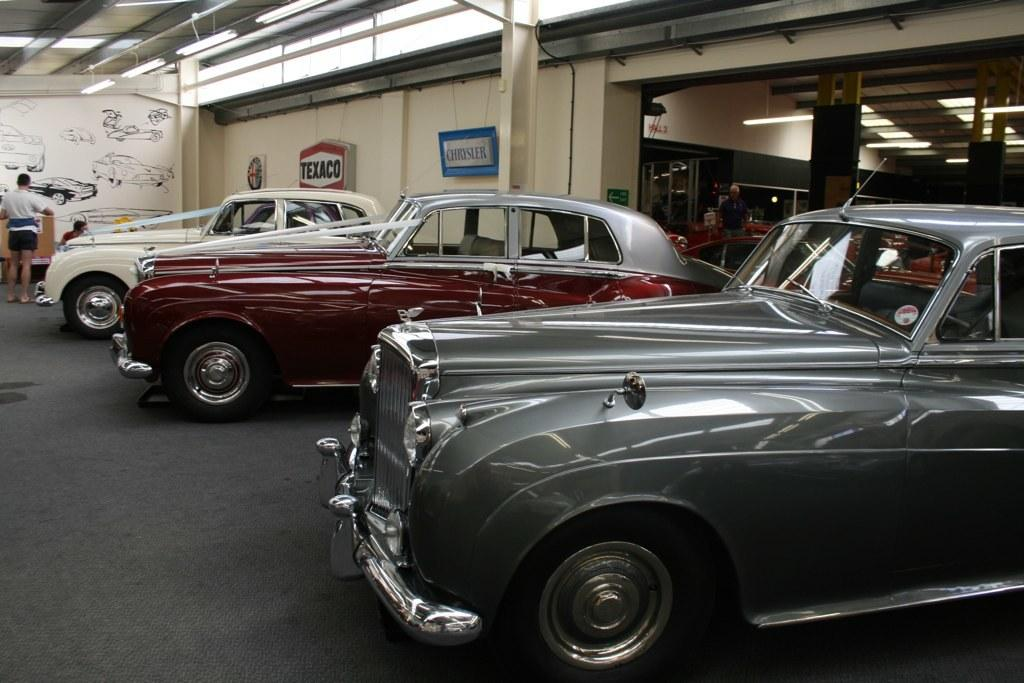What is the main subject of the image? The main subject of the image is many cars. Can you describe one of the cars in the image? One of the cars is gray. Is there anyone else visible in the image besides the cars? Yes, there is a person standing in the background. What can be seen in the background of the image? There is a wall in the background, which is cream-colored, and there are boards hanging on a pole. How does the wrench help to generate heat in the image? There is no wrench present in the image, so it cannot help generate heat. 